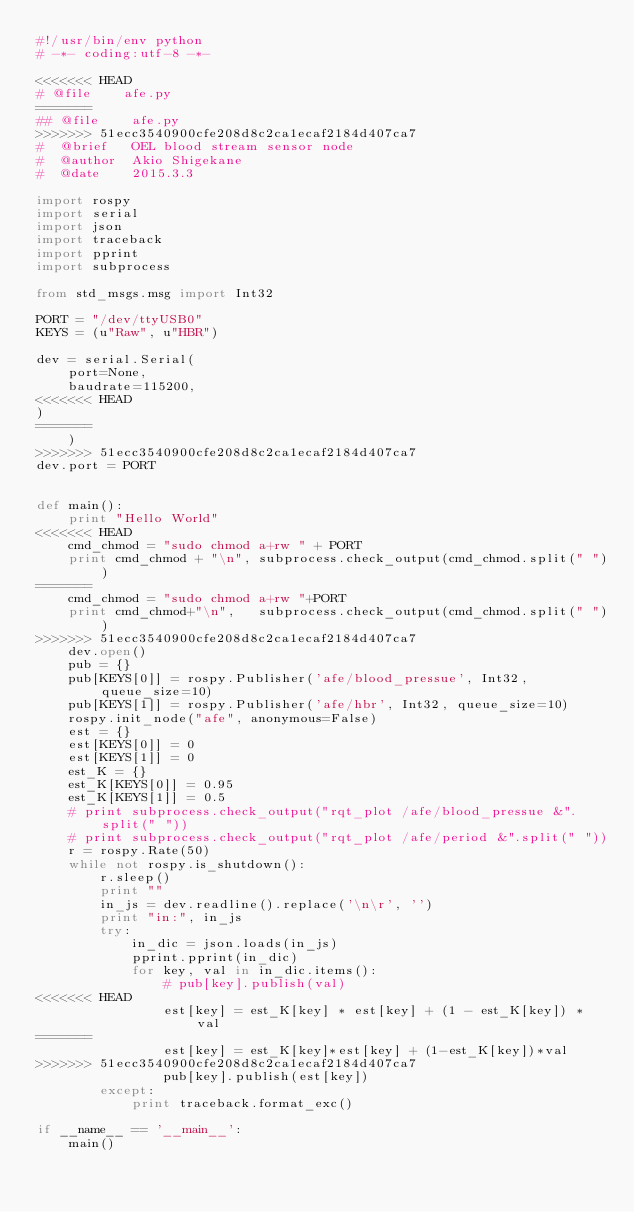<code> <loc_0><loc_0><loc_500><loc_500><_Python_>#!/usr/bin/env python
# -*- coding:utf-8 -*-

<<<<<<< HEAD
# @file    afe.py
=======
## @file    afe.py
>>>>>>> 51ecc3540900cfe208d8c2ca1ecaf2184d407ca7
#  @brief   OEL blood stream sensor node
#  @author  Akio Shigekane
#  @date    2015.3.3

import rospy
import serial
import json
import traceback
import pprint
import subprocess

from std_msgs.msg import Int32

PORT = "/dev/ttyUSB0"
KEYS = (u"Raw", u"HBR")

dev = serial.Serial(
    port=None,
    baudrate=115200,
<<<<<<< HEAD
)
=======
    )
>>>>>>> 51ecc3540900cfe208d8c2ca1ecaf2184d407ca7
dev.port = PORT


def main():
    print "Hello World"
<<<<<<< HEAD
    cmd_chmod = "sudo chmod a+rw " + PORT
    print cmd_chmod + "\n", subprocess.check_output(cmd_chmod.split(" "))
=======
    cmd_chmod = "sudo chmod a+rw "+PORT
    print cmd_chmod+"\n",   subprocess.check_output(cmd_chmod.split(" "))
>>>>>>> 51ecc3540900cfe208d8c2ca1ecaf2184d407ca7
    dev.open()
    pub = {}
    pub[KEYS[0]] = rospy.Publisher('afe/blood_pressue', Int32, queue_size=10)
    pub[KEYS[1]] = rospy.Publisher('afe/hbr', Int32, queue_size=10)
    rospy.init_node("afe", anonymous=False)
    est = {}
    est[KEYS[0]] = 0
    est[KEYS[1]] = 0
    est_K = {}
    est_K[KEYS[0]] = 0.95
    est_K[KEYS[1]] = 0.5
    # print subprocess.check_output("rqt_plot /afe/blood_pressue &".split(" "))
    # print subprocess.check_output("rqt_plot /afe/period &".split(" "))
    r = rospy.Rate(50)
    while not rospy.is_shutdown():
        r.sleep()
        print ""
        in_js = dev.readline().replace('\n\r', '')
        print "in:", in_js
        try:
            in_dic = json.loads(in_js)
            pprint.pprint(in_dic)
            for key, val in in_dic.items():
                # pub[key].publish(val)
<<<<<<< HEAD
                est[key] = est_K[key] * est[key] + (1 - est_K[key]) * val
=======
                est[key] = est_K[key]*est[key] + (1-est_K[key])*val
>>>>>>> 51ecc3540900cfe208d8c2ca1ecaf2184d407ca7
                pub[key].publish(est[key])
        except:
            print traceback.format_exc()

if __name__ == '__main__':
    main()
</code> 